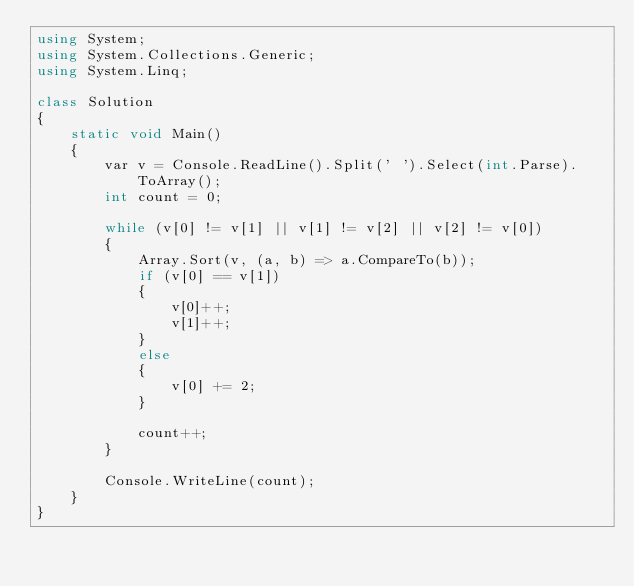Convert code to text. <code><loc_0><loc_0><loc_500><loc_500><_C#_>using System;
using System.Collections.Generic;
using System.Linq;

class Solution
{
    static void Main()
    {
        var v = Console.ReadLine().Split(' ').Select(int.Parse).ToArray();
        int count = 0;

        while (v[0] != v[1] || v[1] != v[2] || v[2] != v[0])
        {
            Array.Sort(v, (a, b) => a.CompareTo(b));
            if (v[0] == v[1])
            {
                v[0]++;
                v[1]++;
            }
            else
            {
                v[0] += 2;
            }

            count++;
        }

        Console.WriteLine(count);
    }
}</code> 